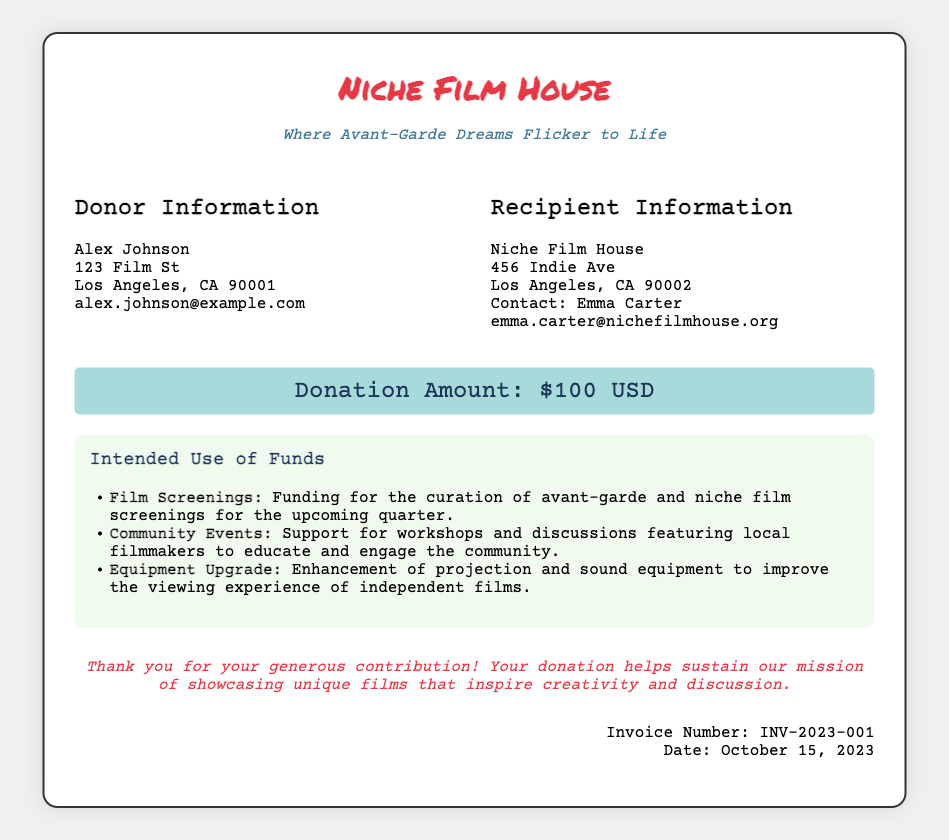What is the name of the donor? The document includes the donor's details, which list the name as Alex Johnson.
Answer: Alex Johnson What is the donation amount? The document specifically states the donation amount, which is highlighted in the amount section.
Answer: $100 USD Who is the contact person for the recipient? The recipient information section mentions the contact person for Niche Film House.
Answer: Emma Carter What is the date of the invoice? The invoice details clearly indicate the date of the transaction, which is mentioned at the bottom right corner.
Answer: October 15, 2023 What is one intended use of the funds? The document lists multiple intended uses for the funds funded by the donation, one of which is highlighted in the intended use section.
Answer: Film Screenings What is the address of the recipient? The recipient information section provides the complete address of Niche Film House.
Answer: 456 Indie Ave, Los Angeles, CA 90002 What is the invoice number? The invoice number is specified at the bottom of the document, identifiable as a unique reference.
Answer: INV-2023-001 What type of events does the donation support? The document describes various initiatives supported by the funds, indicating specific types of events related to community engagement.
Answer: Community Events What is the subtitle of the Niche Film House? The subtitle appears prominently just under the name of the cinema in the header section of the document.
Answer: Where Avant-Garde Dreams Flicker to Life 